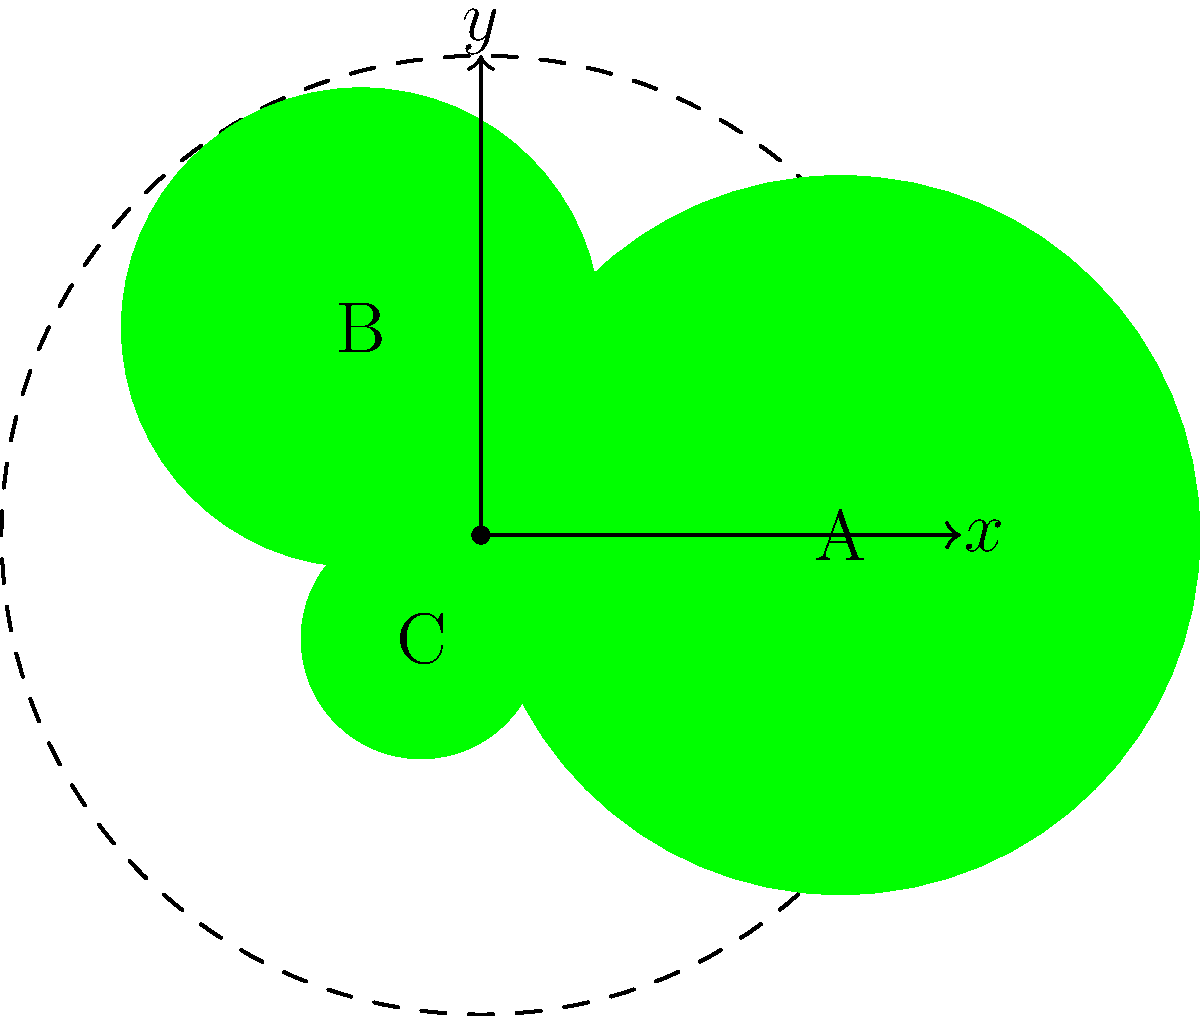You are arranging three Christmas trees of different sizes in a circular display. The trees are placed at equal angular intervals, with their centers forming an equilateral triangle. The largest tree (A) is placed at $(3,0)$ in polar coordinates. If the medium-sized tree (B) has a radius of 2 units and the smallest tree (C) has a radius of 1 unit, what are the polar coordinates $(r,\theta)$ of trees B and C? Let's approach this step-by-step:

1) We know that the trees are placed at equal angular intervals, which means they are $\frac{2\pi}{3}$ radians (or 120°) apart.

2) Tree A is given at $(3,0)$ in polar coordinates, which means $r_A = 3$ and $\theta_A = 0$.

3) For tree B:
   - The angle will be $\theta_B = \frac{2\pi}{3}$ radians (120°)
   - The radius is given as $r_B = 2$

4) For tree C:
   - The angle will be $\theta_C = \frac{4\pi}{3}$ radians (240°)
   - The radius is given as $r_C = 1$

5) Therefore, the polar coordinates are:
   - Tree B: $(2, \frac{2\pi}{3})$
   - Tree C: $(1, \frac{4\pi}{3})$
Answer: B: $(2, \frac{2\pi}{3})$, C: $(1, \frac{4\pi}{3})$ 